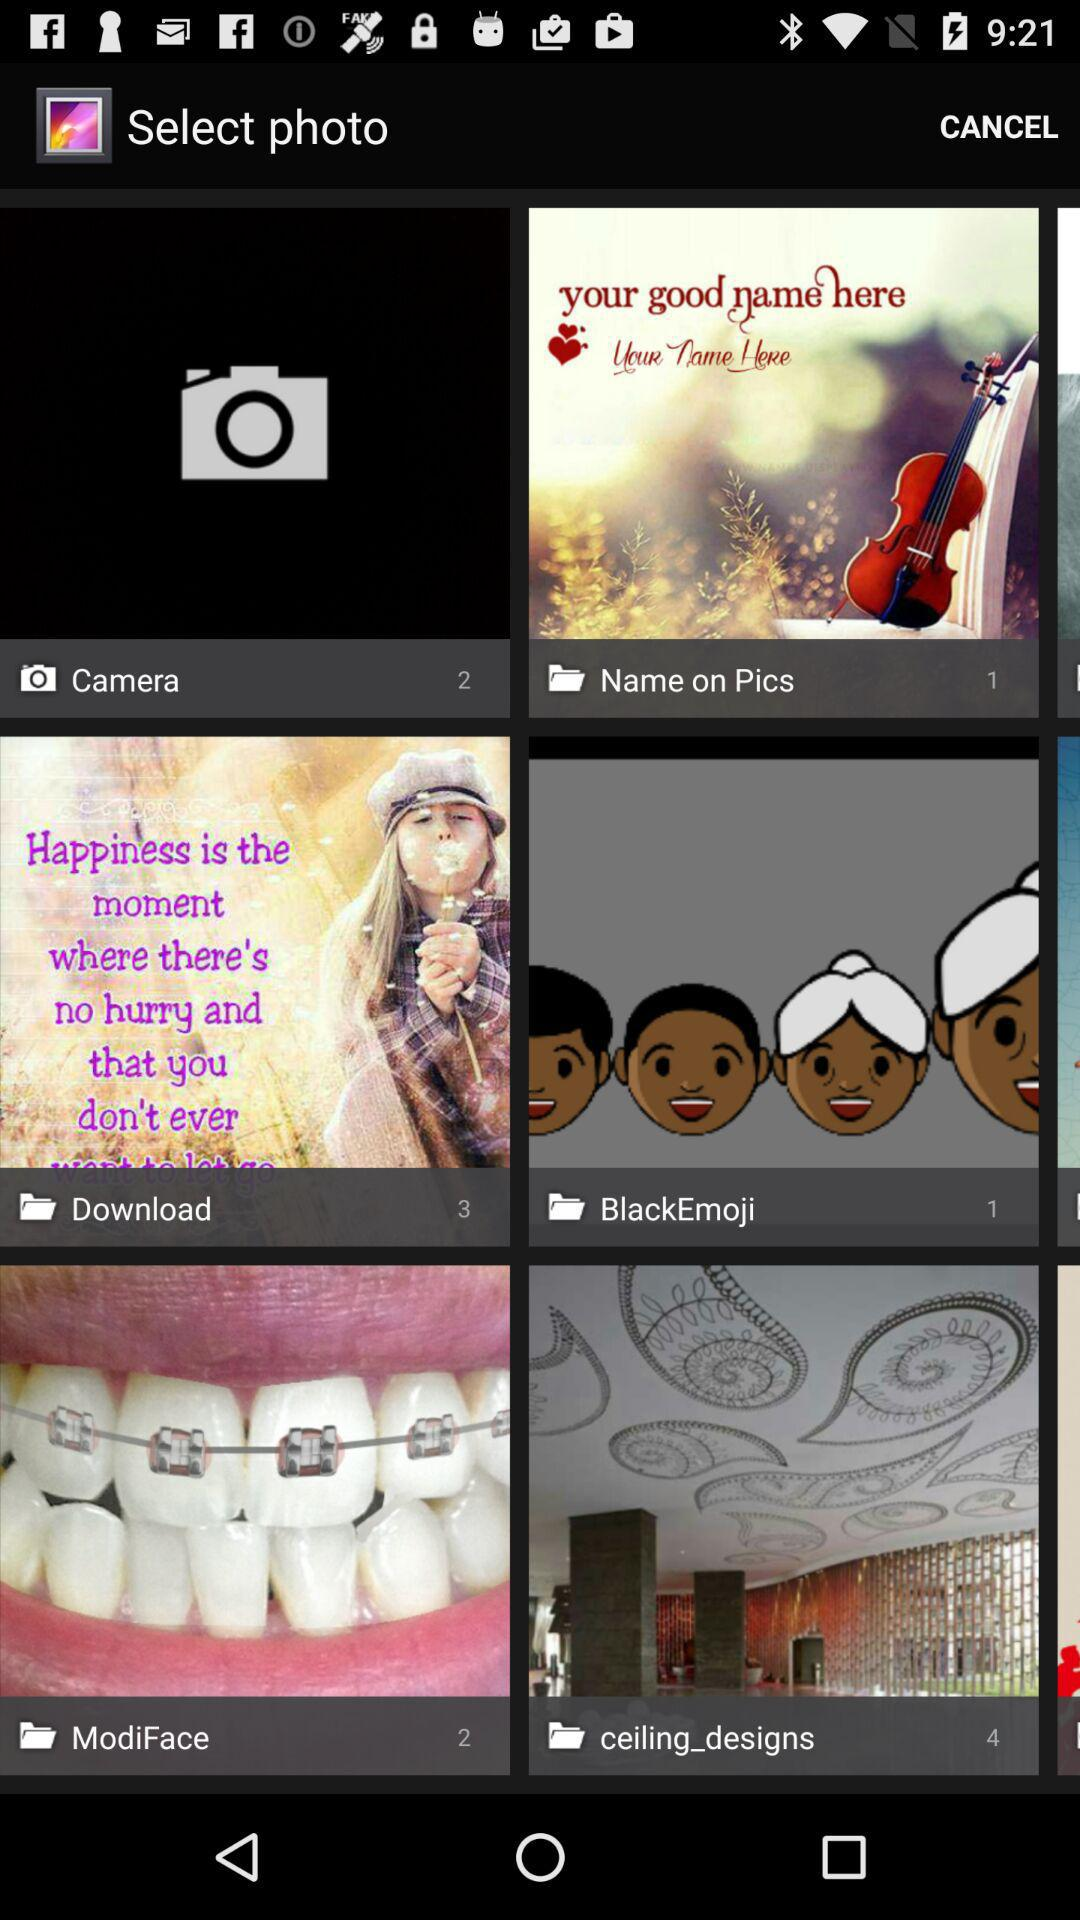How many pictures are in the "Camera" folder? There are 2 pictures in the "Camera" folder. 